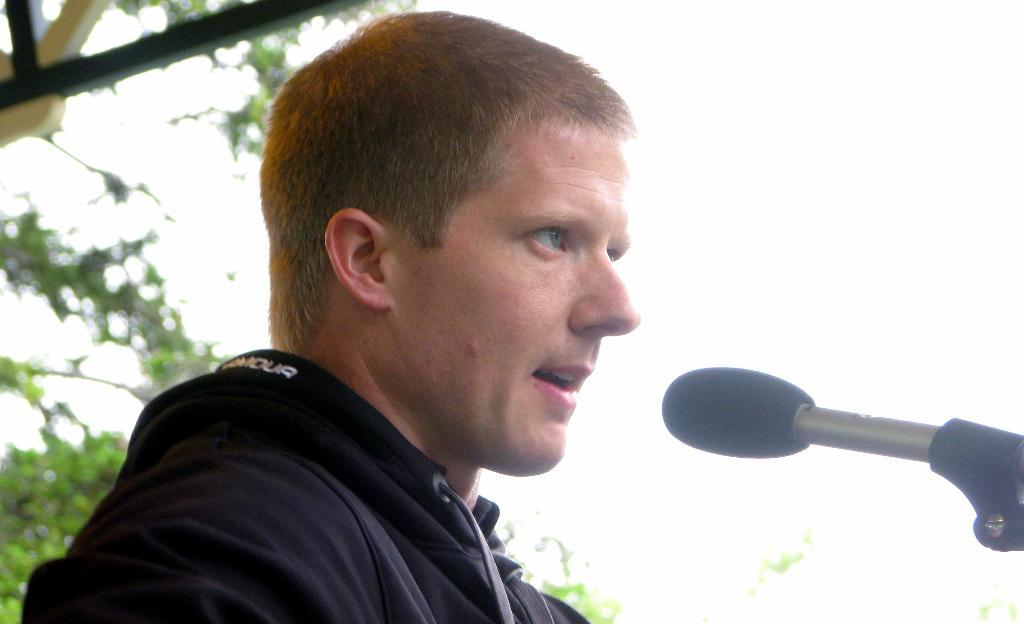Who is the main subject in the image? There is a man in the image. What is the man wearing? The man is wearing a black jacket. What is the man doing in the image? The man is talking into a microphone. What can be seen in the background of the image? There is a tree and the sky visible in the background of the image. What type of quilt is the man using to cover the flower in the image? There is no quilt or flower present in the image; it features a man talking into a microphone with a tree and the sky visible in the background. 